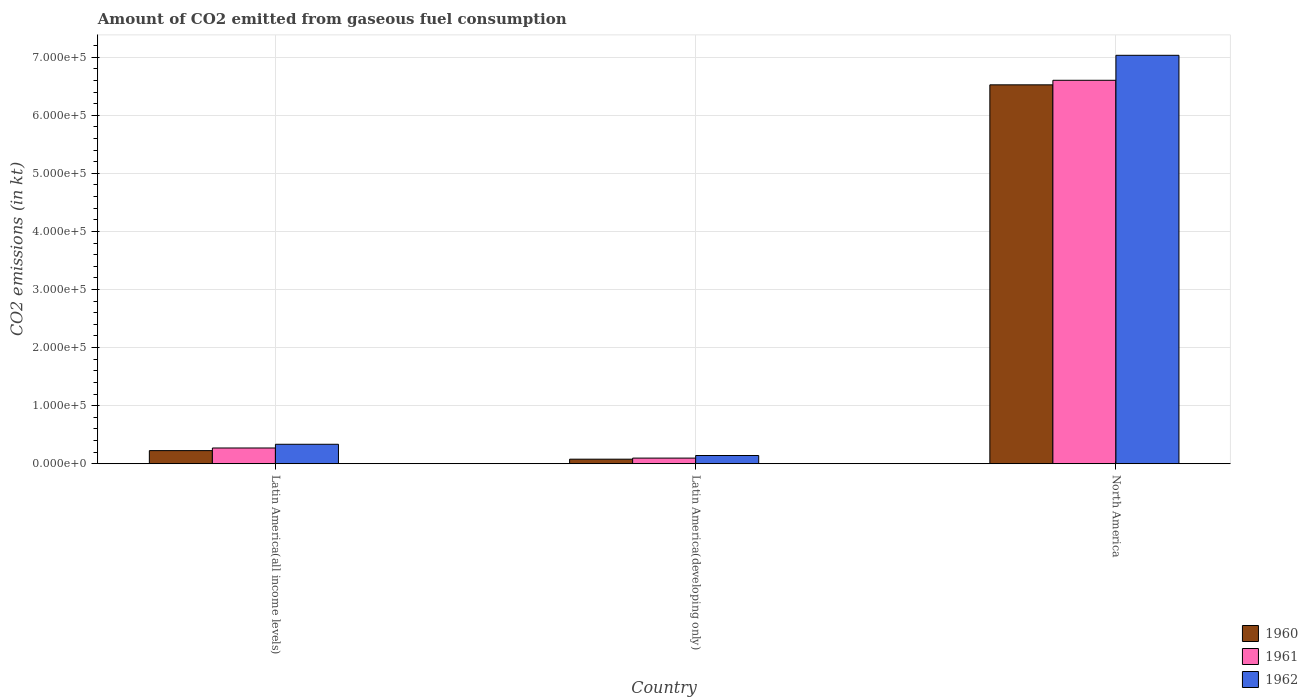How many different coloured bars are there?
Offer a very short reply. 3. How many groups of bars are there?
Provide a short and direct response. 3. Are the number of bars per tick equal to the number of legend labels?
Your response must be concise. Yes. Are the number of bars on each tick of the X-axis equal?
Offer a very short reply. Yes. How many bars are there on the 1st tick from the left?
Provide a succinct answer. 3. How many bars are there on the 3rd tick from the right?
Provide a short and direct response. 3. What is the label of the 2nd group of bars from the left?
Offer a very short reply. Latin America(developing only). In how many cases, is the number of bars for a given country not equal to the number of legend labels?
Your response must be concise. 0. What is the amount of CO2 emitted in 1960 in Latin America(all income levels)?
Offer a terse response. 2.26e+04. Across all countries, what is the maximum amount of CO2 emitted in 1962?
Your answer should be very brief. 7.03e+05. Across all countries, what is the minimum amount of CO2 emitted in 1960?
Ensure brevity in your answer.  7838.55. In which country was the amount of CO2 emitted in 1961 minimum?
Ensure brevity in your answer.  Latin America(developing only). What is the total amount of CO2 emitted in 1960 in the graph?
Ensure brevity in your answer.  6.83e+05. What is the difference between the amount of CO2 emitted in 1962 in Latin America(developing only) and that in North America?
Provide a short and direct response. -6.89e+05. What is the difference between the amount of CO2 emitted in 1960 in North America and the amount of CO2 emitted in 1961 in Latin America(developing only)?
Offer a very short reply. 6.43e+05. What is the average amount of CO2 emitted in 1960 per country?
Your response must be concise. 2.28e+05. What is the difference between the amount of CO2 emitted of/in 1961 and amount of CO2 emitted of/in 1960 in Latin America(developing only)?
Offer a terse response. 1876.23. What is the ratio of the amount of CO2 emitted in 1960 in Latin America(all income levels) to that in North America?
Provide a short and direct response. 0.03. Is the difference between the amount of CO2 emitted in 1961 in Latin America(all income levels) and Latin America(developing only) greater than the difference between the amount of CO2 emitted in 1960 in Latin America(all income levels) and Latin America(developing only)?
Your answer should be compact. Yes. What is the difference between the highest and the second highest amount of CO2 emitted in 1960?
Provide a short and direct response. 6.30e+05. What is the difference between the highest and the lowest amount of CO2 emitted in 1962?
Your response must be concise. 6.89e+05. What does the 2nd bar from the right in North America represents?
Provide a short and direct response. 1961. Does the graph contain any zero values?
Keep it short and to the point. No. How many legend labels are there?
Offer a very short reply. 3. What is the title of the graph?
Give a very brief answer. Amount of CO2 emitted from gaseous fuel consumption. What is the label or title of the X-axis?
Your answer should be very brief. Country. What is the label or title of the Y-axis?
Your response must be concise. CO2 emissions (in kt). What is the CO2 emissions (in kt) in 1960 in Latin America(all income levels)?
Your answer should be compact. 2.26e+04. What is the CO2 emissions (in kt) in 1961 in Latin America(all income levels)?
Keep it short and to the point. 2.71e+04. What is the CO2 emissions (in kt) of 1962 in Latin America(all income levels)?
Provide a short and direct response. 3.35e+04. What is the CO2 emissions (in kt) in 1960 in Latin America(developing only)?
Your response must be concise. 7838.55. What is the CO2 emissions (in kt) in 1961 in Latin America(developing only)?
Provide a succinct answer. 9714.77. What is the CO2 emissions (in kt) of 1962 in Latin America(developing only)?
Your answer should be compact. 1.42e+04. What is the CO2 emissions (in kt) in 1960 in North America?
Give a very brief answer. 6.52e+05. What is the CO2 emissions (in kt) of 1961 in North America?
Provide a short and direct response. 6.60e+05. What is the CO2 emissions (in kt) in 1962 in North America?
Keep it short and to the point. 7.03e+05. Across all countries, what is the maximum CO2 emissions (in kt) in 1960?
Provide a succinct answer. 6.52e+05. Across all countries, what is the maximum CO2 emissions (in kt) in 1961?
Make the answer very short. 6.60e+05. Across all countries, what is the maximum CO2 emissions (in kt) in 1962?
Ensure brevity in your answer.  7.03e+05. Across all countries, what is the minimum CO2 emissions (in kt) in 1960?
Provide a succinct answer. 7838.55. Across all countries, what is the minimum CO2 emissions (in kt) in 1961?
Your response must be concise. 9714.77. Across all countries, what is the minimum CO2 emissions (in kt) in 1962?
Your answer should be very brief. 1.42e+04. What is the total CO2 emissions (in kt) in 1960 in the graph?
Give a very brief answer. 6.83e+05. What is the total CO2 emissions (in kt) in 1961 in the graph?
Your answer should be compact. 6.97e+05. What is the total CO2 emissions (in kt) in 1962 in the graph?
Provide a succinct answer. 7.51e+05. What is the difference between the CO2 emissions (in kt) of 1960 in Latin America(all income levels) and that in Latin America(developing only)?
Provide a short and direct response. 1.47e+04. What is the difference between the CO2 emissions (in kt) of 1961 in Latin America(all income levels) and that in Latin America(developing only)?
Offer a very short reply. 1.74e+04. What is the difference between the CO2 emissions (in kt) in 1962 in Latin America(all income levels) and that in Latin America(developing only)?
Offer a terse response. 1.93e+04. What is the difference between the CO2 emissions (in kt) in 1960 in Latin America(all income levels) and that in North America?
Keep it short and to the point. -6.30e+05. What is the difference between the CO2 emissions (in kt) of 1961 in Latin America(all income levels) and that in North America?
Your answer should be very brief. -6.33e+05. What is the difference between the CO2 emissions (in kt) in 1962 in Latin America(all income levels) and that in North America?
Your answer should be compact. -6.70e+05. What is the difference between the CO2 emissions (in kt) of 1960 in Latin America(developing only) and that in North America?
Offer a very short reply. -6.45e+05. What is the difference between the CO2 emissions (in kt) in 1961 in Latin America(developing only) and that in North America?
Your answer should be compact. -6.50e+05. What is the difference between the CO2 emissions (in kt) in 1962 in Latin America(developing only) and that in North America?
Offer a terse response. -6.89e+05. What is the difference between the CO2 emissions (in kt) of 1960 in Latin America(all income levels) and the CO2 emissions (in kt) of 1961 in Latin America(developing only)?
Provide a succinct answer. 1.29e+04. What is the difference between the CO2 emissions (in kt) in 1960 in Latin America(all income levels) and the CO2 emissions (in kt) in 1962 in Latin America(developing only)?
Provide a succinct answer. 8397.37. What is the difference between the CO2 emissions (in kt) of 1961 in Latin America(all income levels) and the CO2 emissions (in kt) of 1962 in Latin America(developing only)?
Your answer should be very brief. 1.29e+04. What is the difference between the CO2 emissions (in kt) of 1960 in Latin America(all income levels) and the CO2 emissions (in kt) of 1961 in North America?
Your response must be concise. -6.38e+05. What is the difference between the CO2 emissions (in kt) of 1960 in Latin America(all income levels) and the CO2 emissions (in kt) of 1962 in North America?
Make the answer very short. -6.81e+05. What is the difference between the CO2 emissions (in kt) of 1961 in Latin America(all income levels) and the CO2 emissions (in kt) of 1962 in North America?
Your response must be concise. -6.76e+05. What is the difference between the CO2 emissions (in kt) of 1960 in Latin America(developing only) and the CO2 emissions (in kt) of 1961 in North America?
Make the answer very short. -6.52e+05. What is the difference between the CO2 emissions (in kt) of 1960 in Latin America(developing only) and the CO2 emissions (in kt) of 1962 in North America?
Give a very brief answer. -6.95e+05. What is the difference between the CO2 emissions (in kt) in 1961 in Latin America(developing only) and the CO2 emissions (in kt) in 1962 in North America?
Your response must be concise. -6.93e+05. What is the average CO2 emissions (in kt) in 1960 per country?
Provide a short and direct response. 2.28e+05. What is the average CO2 emissions (in kt) in 1961 per country?
Offer a terse response. 2.32e+05. What is the average CO2 emissions (in kt) of 1962 per country?
Give a very brief answer. 2.50e+05. What is the difference between the CO2 emissions (in kt) in 1960 and CO2 emissions (in kt) in 1961 in Latin America(all income levels)?
Your answer should be very brief. -4542.92. What is the difference between the CO2 emissions (in kt) in 1960 and CO2 emissions (in kt) in 1962 in Latin America(all income levels)?
Your response must be concise. -1.09e+04. What is the difference between the CO2 emissions (in kt) of 1961 and CO2 emissions (in kt) of 1962 in Latin America(all income levels)?
Provide a short and direct response. -6377.63. What is the difference between the CO2 emissions (in kt) in 1960 and CO2 emissions (in kt) in 1961 in Latin America(developing only)?
Your answer should be compact. -1876.23. What is the difference between the CO2 emissions (in kt) in 1960 and CO2 emissions (in kt) in 1962 in Latin America(developing only)?
Provide a short and direct response. -6343.06. What is the difference between the CO2 emissions (in kt) of 1961 and CO2 emissions (in kt) of 1962 in Latin America(developing only)?
Your answer should be very brief. -4466.83. What is the difference between the CO2 emissions (in kt) in 1960 and CO2 emissions (in kt) in 1961 in North America?
Provide a succinct answer. -7828.66. What is the difference between the CO2 emissions (in kt) in 1960 and CO2 emissions (in kt) in 1962 in North America?
Your answer should be compact. -5.08e+04. What is the difference between the CO2 emissions (in kt) in 1961 and CO2 emissions (in kt) in 1962 in North America?
Provide a succinct answer. -4.30e+04. What is the ratio of the CO2 emissions (in kt) in 1960 in Latin America(all income levels) to that in Latin America(developing only)?
Your answer should be compact. 2.88. What is the ratio of the CO2 emissions (in kt) of 1961 in Latin America(all income levels) to that in Latin America(developing only)?
Make the answer very short. 2.79. What is the ratio of the CO2 emissions (in kt) in 1962 in Latin America(all income levels) to that in Latin America(developing only)?
Your response must be concise. 2.36. What is the ratio of the CO2 emissions (in kt) of 1960 in Latin America(all income levels) to that in North America?
Offer a terse response. 0.03. What is the ratio of the CO2 emissions (in kt) of 1961 in Latin America(all income levels) to that in North America?
Your answer should be very brief. 0.04. What is the ratio of the CO2 emissions (in kt) in 1962 in Latin America(all income levels) to that in North America?
Provide a succinct answer. 0.05. What is the ratio of the CO2 emissions (in kt) in 1960 in Latin America(developing only) to that in North America?
Offer a terse response. 0.01. What is the ratio of the CO2 emissions (in kt) in 1961 in Latin America(developing only) to that in North America?
Ensure brevity in your answer.  0.01. What is the ratio of the CO2 emissions (in kt) of 1962 in Latin America(developing only) to that in North America?
Your answer should be very brief. 0.02. What is the difference between the highest and the second highest CO2 emissions (in kt) of 1960?
Provide a succinct answer. 6.30e+05. What is the difference between the highest and the second highest CO2 emissions (in kt) in 1961?
Keep it short and to the point. 6.33e+05. What is the difference between the highest and the second highest CO2 emissions (in kt) in 1962?
Provide a short and direct response. 6.70e+05. What is the difference between the highest and the lowest CO2 emissions (in kt) of 1960?
Offer a very short reply. 6.45e+05. What is the difference between the highest and the lowest CO2 emissions (in kt) of 1961?
Ensure brevity in your answer.  6.50e+05. What is the difference between the highest and the lowest CO2 emissions (in kt) of 1962?
Provide a succinct answer. 6.89e+05. 